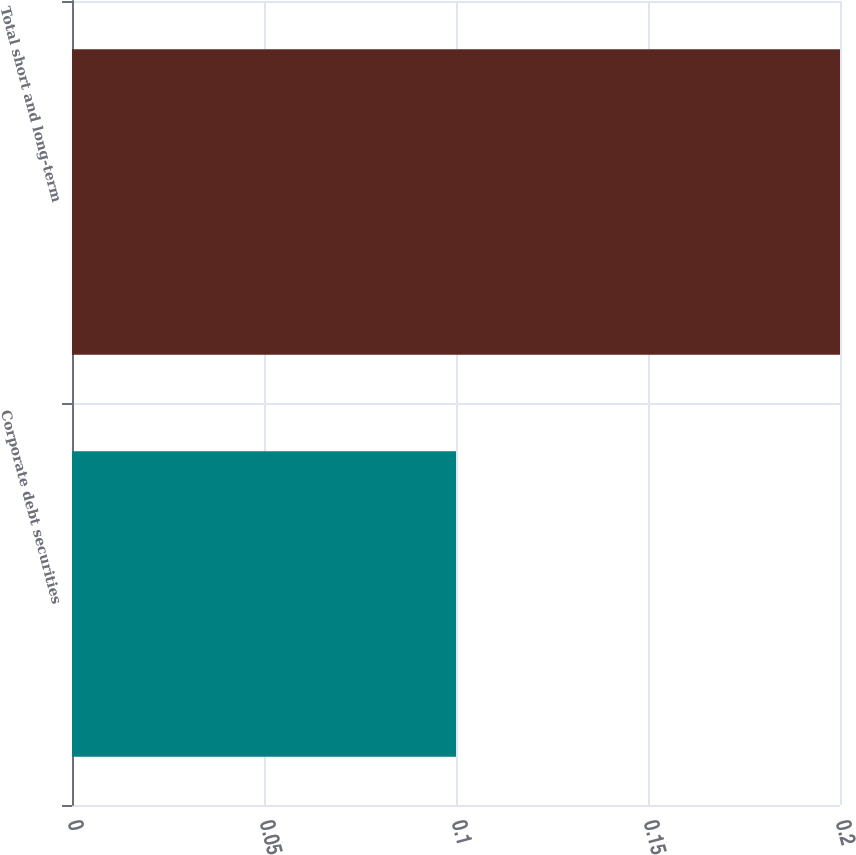Convert chart to OTSL. <chart><loc_0><loc_0><loc_500><loc_500><bar_chart><fcel>Corporate debt securities<fcel>Total short and long-term<nl><fcel>0.1<fcel>0.2<nl></chart> 